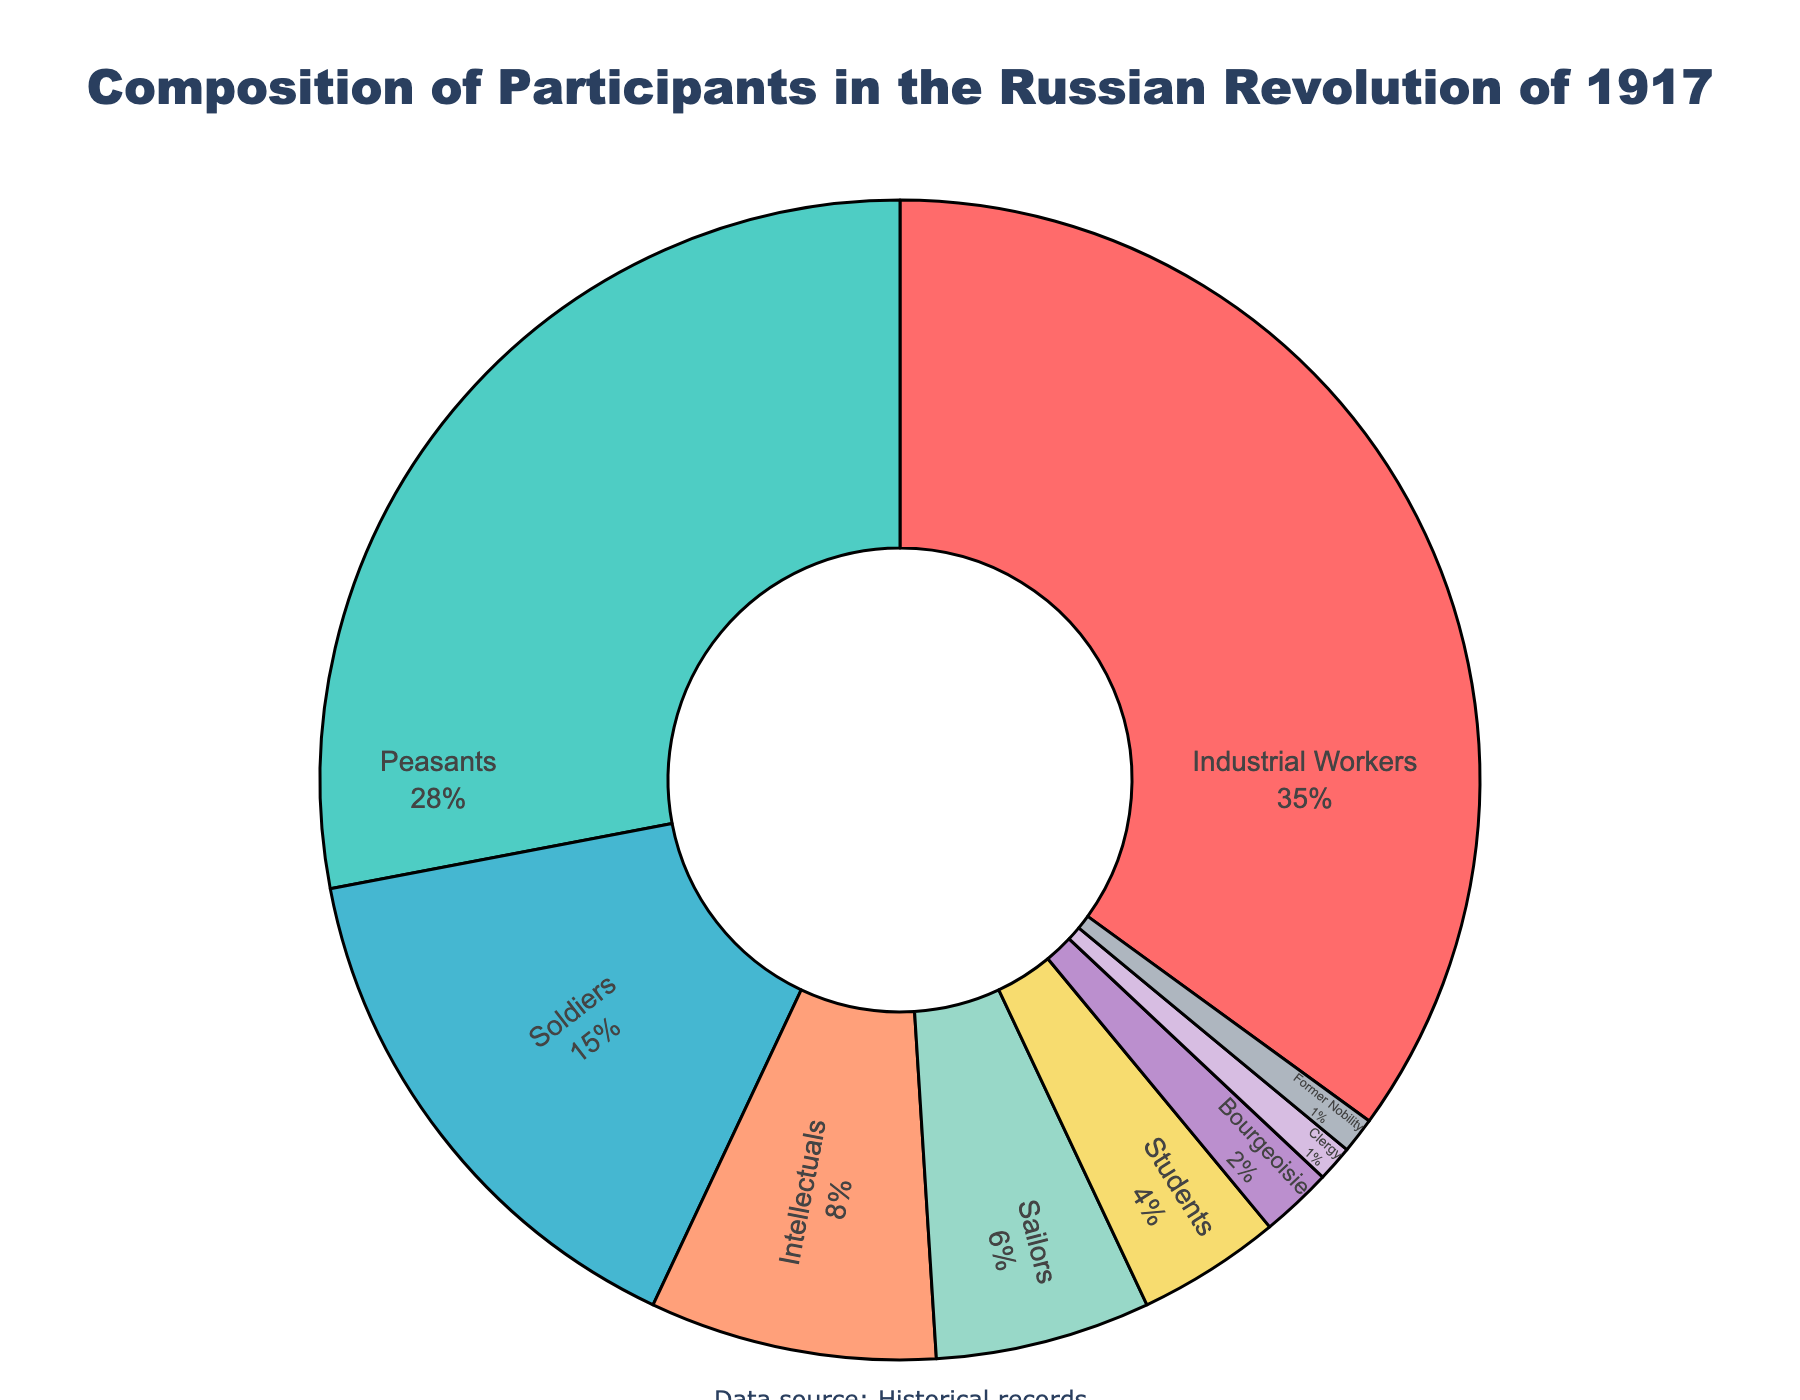What percentage of participants were either Industrial Workers or Peasants? Sum the percentages for Industrial Workers and Peasants: 35% (Industrial Workers) + 28% (Peasants) = 63%
Answer: 63% Who represents a larger portion: Soldiers or Sailors? Compare the percentages for Soldiers and Sailors: Soldiers have 15% and Sailors have 6%, so Soldiers represent the larger portion
Answer: Soldiers What is the sum of the percentages for Intellectuals, Students, and Former Nobility? Sum the percentages for Intellectuals, Students, and Former Nobility: 8% (Intellectuals) + 4% (Students) + 1% (Former Nobility) = 13%
Answer: 13% Which occupation group has the smallest representation in the participants? Identify the group with the smallest percentage: Clergy and Former Nobility both have 1%
Answer: Clergy and Former Nobility Is the combined percentage of Intellectuals and Students greater than that of Peasants? Sum the percentages for Intellectuals and Students and compare it to Peasants: 8% (Intellectuals) + 4% (Students) = 12%, which is less than 28% (Peasants)
Answer: No What is the difference in percentage between Industrial Workers and Bourgeoisie? Subtract the percentage of Bourgeoisie from that of Industrial Workers: 35% (Industrial Workers) - 2% (Bourgeoisie) = 33%
Answer: 33% Which three occupation groups have a combined percentage closest to 50%? Sum the combinations: Industrial Workers (35%), Peasants (28%), and Soldiers (15%) = 78%; Industrial Workers (35%), Peasants (28%), Intellectuals (8%) = 71%; Industrial Workers (35%), Peasants (28%), Sailors (6%) = 69%; ...; Peasants (28%), Soldiers (15%), Intellectuals (8%) = 51%; Peasants (28%), Soldiers (15%), Sailors (6%) = 49% - Peasants, Soldiers, and Sailors are closest to 50%
Answer: Peasants, Soldiers, and Sailors Considering the visual colors in the pie chart, which color sector represents the Bourgeoisie? Identify the color associated with the Bourgeoisie slice in the chart. The pie chart uses distinct colors for each category. The Bourgeoisie slice is typically marked by one of the final (least used) colors often found at or near the bottom in the legend. In this case, it might be pale blue or a lighter color as it is a small percentage.
Answer: Pale blue (or light color) 